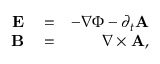<formula> <loc_0><loc_0><loc_500><loc_500>\begin{array} { r l r } { E } & = } & { - \nabla \Phi - \partial _ { t } { A } } \\ { B } & = } & { \nabla \times { A } , } \end{array}</formula> 